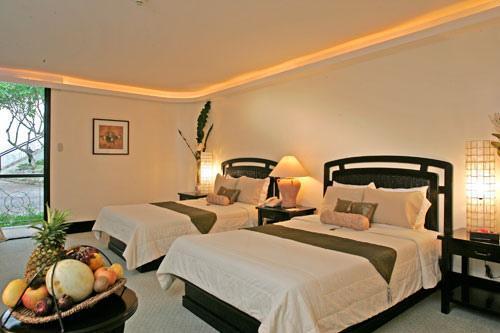How many beds are in the picture?
Give a very brief answer. 2. 